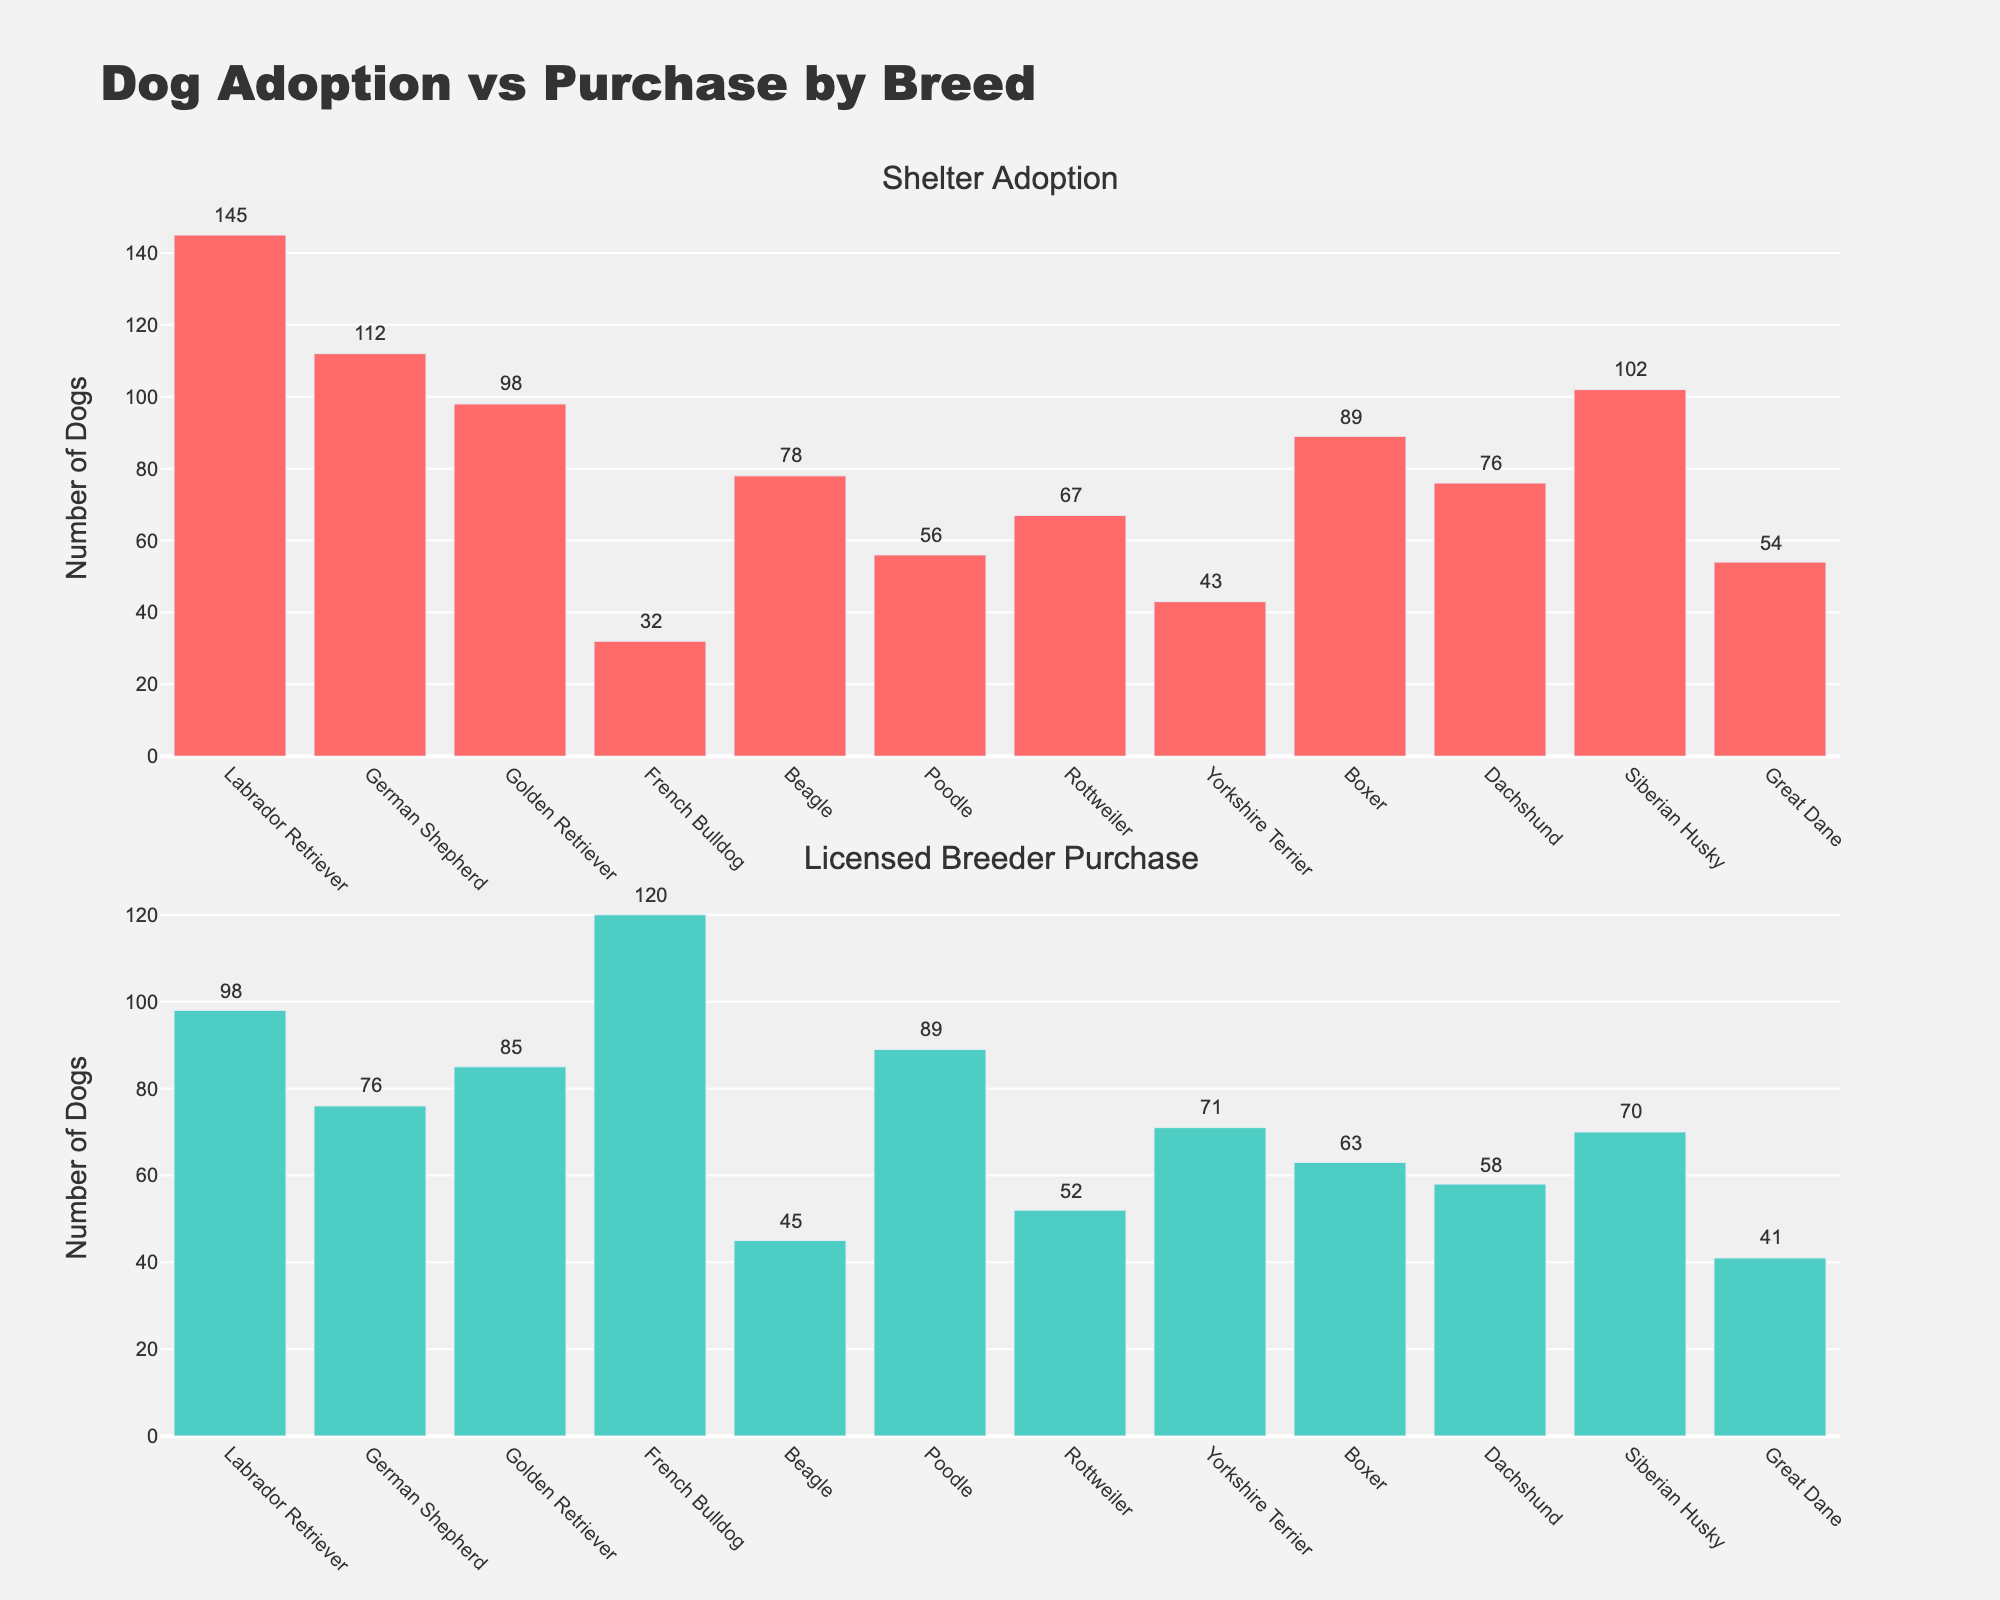What breed has the highest number of shelter adoptions? Looking at the first subplot for shelter adoptions, the Labrador Retriever has the highest bar.
Answer: Labrador Retriever Which breed has the smallest difference between shelter adoptions and licensed breeder purchases? Calculating the difference for each breed, the Great Danes have a difference of 13 (54-41). It is the smallest among all breeds.
Answer: Great Dane How many breeds have higher licensed breeder purchases compared to shelter adoptions? By comparing each bar in both subplots, there are four breeds: French Bulldog, Poodle, Yorkshire Terrier, and Great Dane have higher licensed breeder purchases than shelter adoptions.
Answer: Four breeds What is the total number of dogs adopted from shelters across all breeds? Summing the numbers in the Shelter Adoption subplot: 145 + 112 + 98 + 32 + 78 + 56 + 67 + 43 + 89 + 76 + 102 + 54 = 952
Answer: 952 Which breed has the largest gap between shelter adoptions and licensed breeder purchases? The largest gap is calculated by finding the absolute difference for each breed. The French Bulldog has the largest gap with a difference of 88 (120-32).
Answer: French Bulldog What is the average number of licensed breeder purchases per breed? To find the average, sum all licensed breeder purchases and divide by the number of breeds: (98+76+85+120+45+89+52+71+63+58+70+41)/12 = 74.75
Answer: 74.75 Which breed has the second-highest number of shelter adoptions? The breed with the second-highest shelter adoptions can be identified as the German Shepherd, with 112 adoptions, just after the Labrador Retriever.
Answer: German Shepherd What is the difference between the total number of shelter adoptions and licensed breeder purchases? Sum the values for shelter adoptions and licensed breeder purchases, and then find the difference: Shelter Adoption = 952, Licensed Breeder Purchase = 868, Difference = 952 - 868 = 84
Answer: 84 